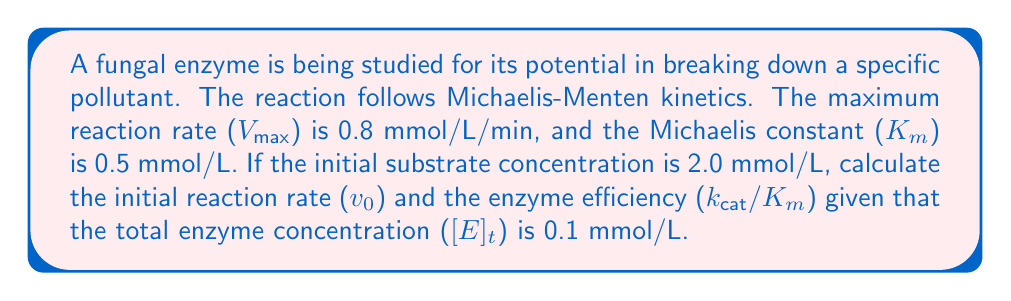Solve this math problem. 1. To calculate the initial reaction rate ($v_0$), we use the Michaelis-Menten equation:

   $$v_0 = \frac{V_{max}[S]}{K_m + [S]}$$

   Where:
   $V_{max} = 0.8$ mmol/L/min
   $K_m = 0.5$ mmol/L
   $[S] = 2.0$ mmol/L

2. Substituting these values:

   $$v_0 = \frac{0.8 \times 2.0}{0.5 + 2.0} = \frac{1.6}{2.5} = 0.64$$ mmol/L/min

3. To calculate enzyme efficiency ($k_{cat}/K_m$), we first need to find $k_{cat}$:

   $k_{cat}$ is the turnover number, which is the maximum number of substrate molecules converted to product per enzyme molecule per second.

   $$k_{cat} = \frac{V_{max}}{[E]_t}$$

4. Converting $V_{max}$ to per second:
   
   $$V_{max} = 0.8 \text{ mmol/L/min} = 0.0133 \text{ mmol/L/s}$$

5. Calculating $k_{cat}$:

   $$k_{cat} = \frac{0.0133}{0.1} = 0.133 \text{ s}^{-1}$$

6. Now we can calculate enzyme efficiency:

   $$\frac{k_{cat}}{K_m} = \frac{0.133}{0.5} = 0.266 \text{ L/(mmol·s)}$$
Answer: $v_0 = 0.64$ mmol/L/min; $k_{cat}/K_m = 0.266$ L/(mmol·s) 